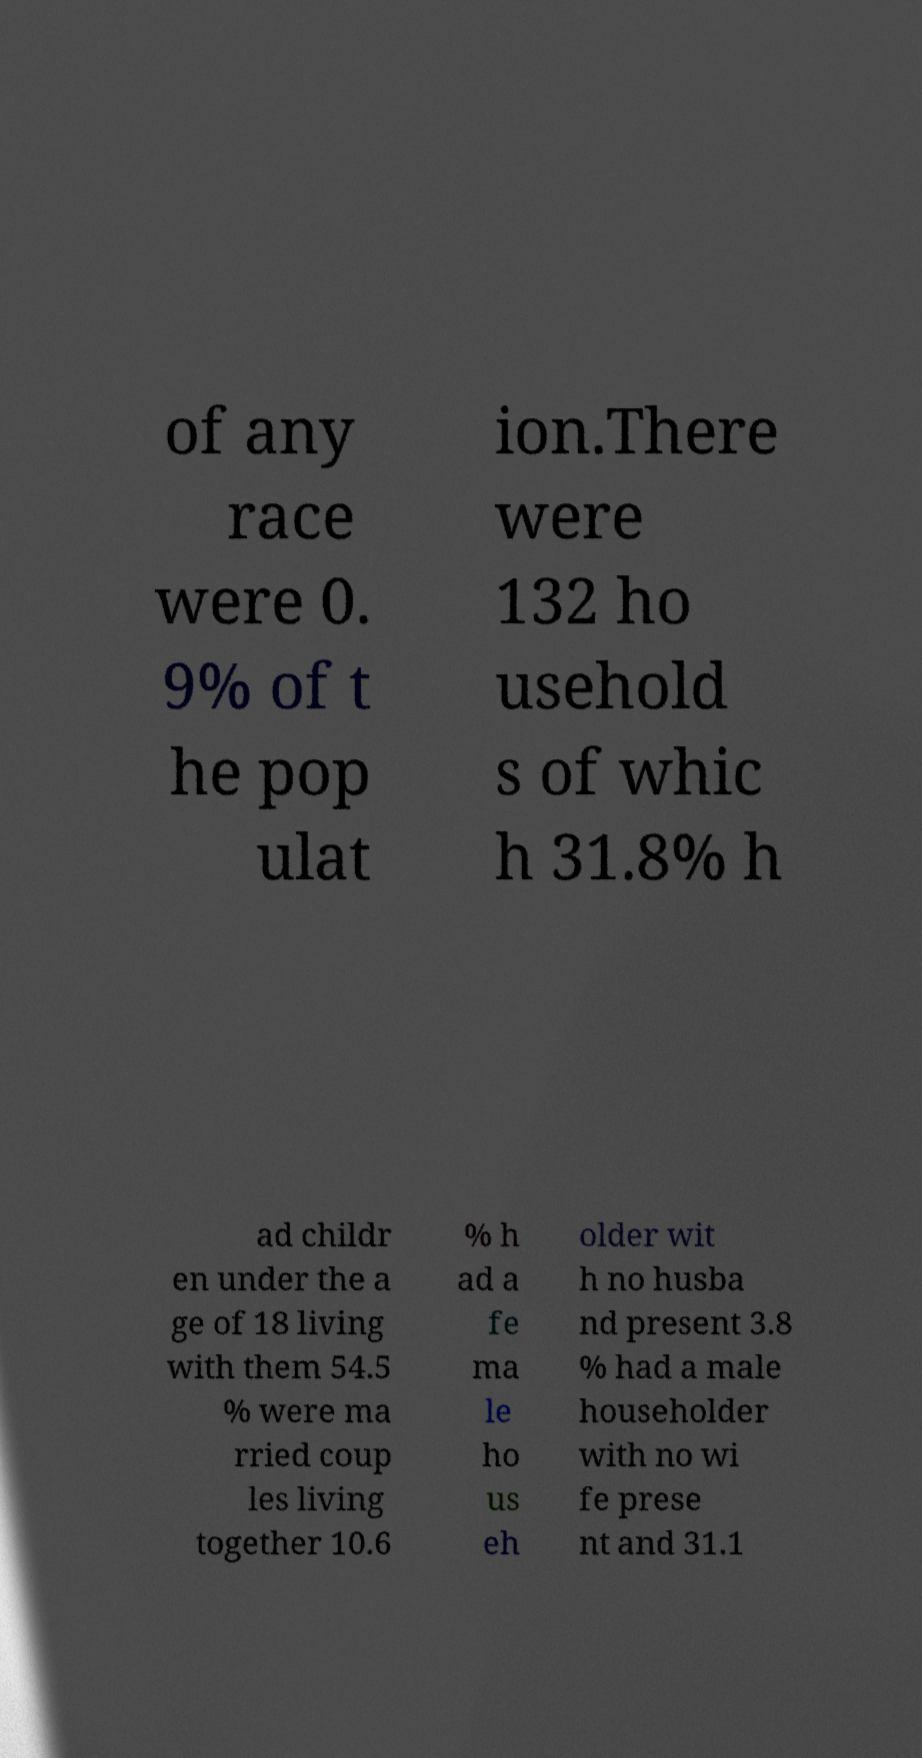For documentation purposes, I need the text within this image transcribed. Could you provide that? of any race were 0. 9% of t he pop ulat ion.There were 132 ho usehold s of whic h 31.8% h ad childr en under the a ge of 18 living with them 54.5 % were ma rried coup les living together 10.6 % h ad a fe ma le ho us eh older wit h no husba nd present 3.8 % had a male householder with no wi fe prese nt and 31.1 